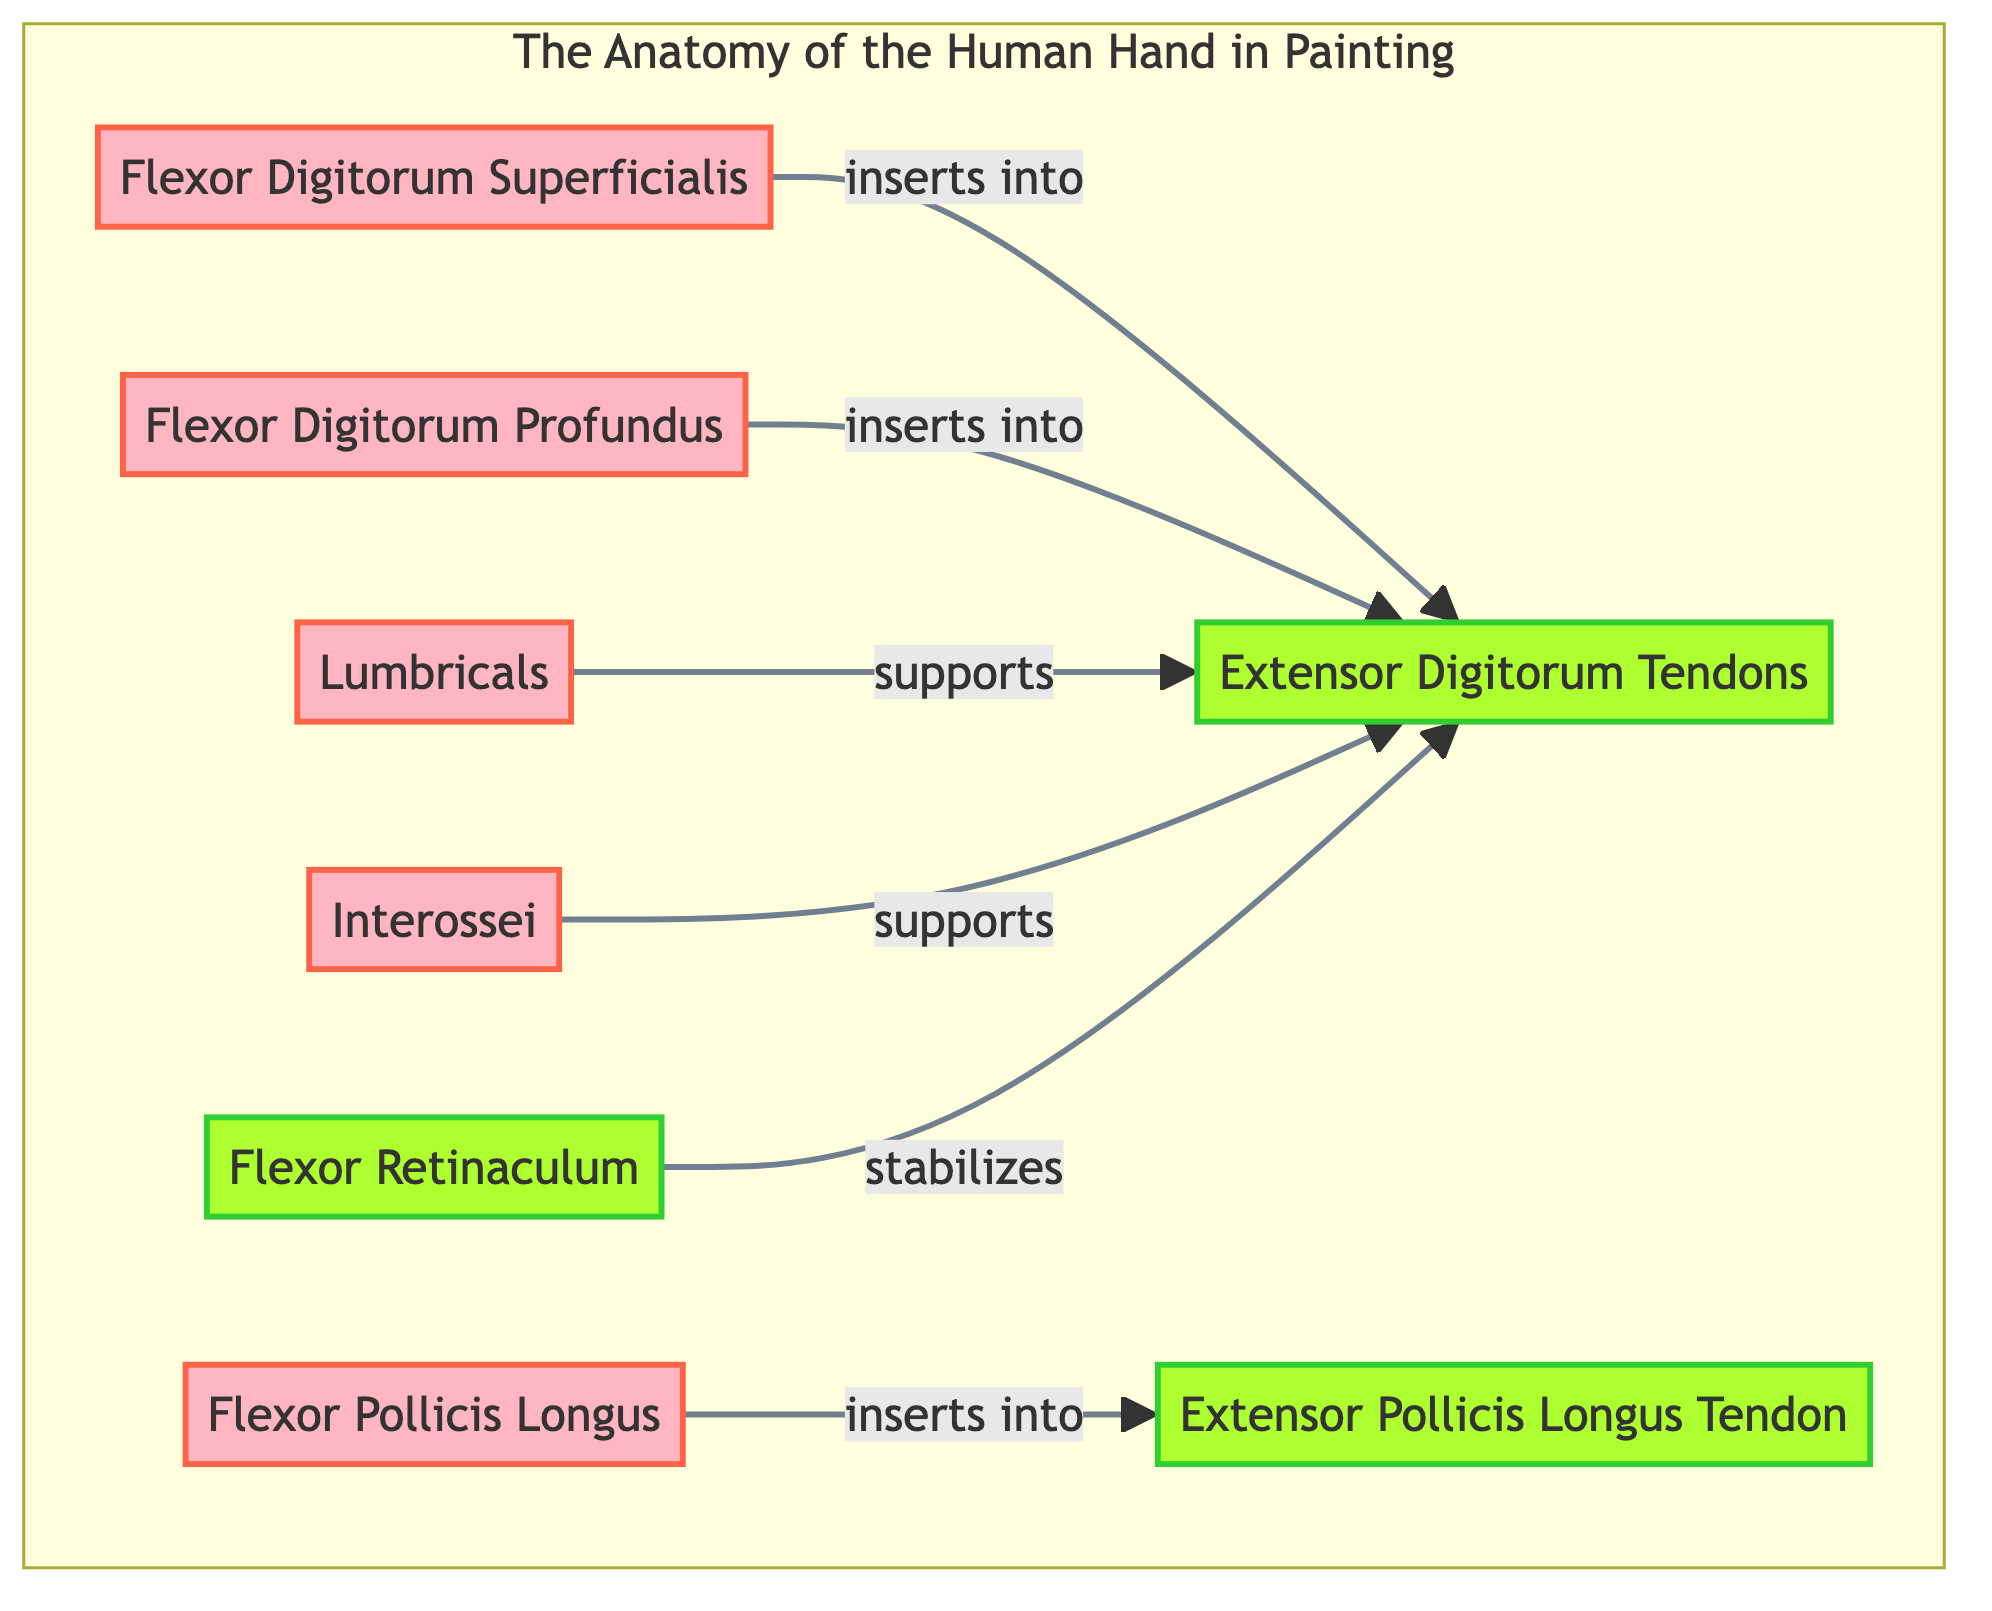What are the highlighted muscles in the diagram? The diagram emphasizes three specific muscles: the Flexor Digitorum Superficialis, Flexor Digitorum Profundus, and Flexor Pollicis Longus. These muscles are visually distinguished by a pink gradient overlay.
Answer: Flexor Digitorum Superficialis, Flexor Digitorum Profundus, Flexor Pollicis Longus How many tendons are represented in the diagram? There are two main tendons shown in the diagram: the Extensor Digitorum Tendons and the Extensor Pollicis Longus Tendon. Each tendon is identified with a green overlay.
Answer: 2 What is the relationship between the Lumbricals and the Extensor Digitorum Tendons? The Lumbricals are shown to support the Extensor Digitorum Tendons, indicating a functional relationship where they help facilitate finger movement or control.
Answer: supports Which tendon stabilizes the Extensor Digitorum Tendons? The Flexor Retinaculum is indicated as the tendon that stabilizes the Extensor Digitorum Tendons, showing its importance in maintaining the positioning of these tendons during movement.
Answer: Flexor Retinaculum Which muscles insert into the Extensor Digitorum Tendons? Both the Flexor Digitorum Superficialis and the Flexor Digitorum Profundus insert into the Extensor Digitorum Tendons, indicating their role in flexing the fingers.
Answer: Flexor Digitorum Superficialis, Flexor Digitorum Profundus 